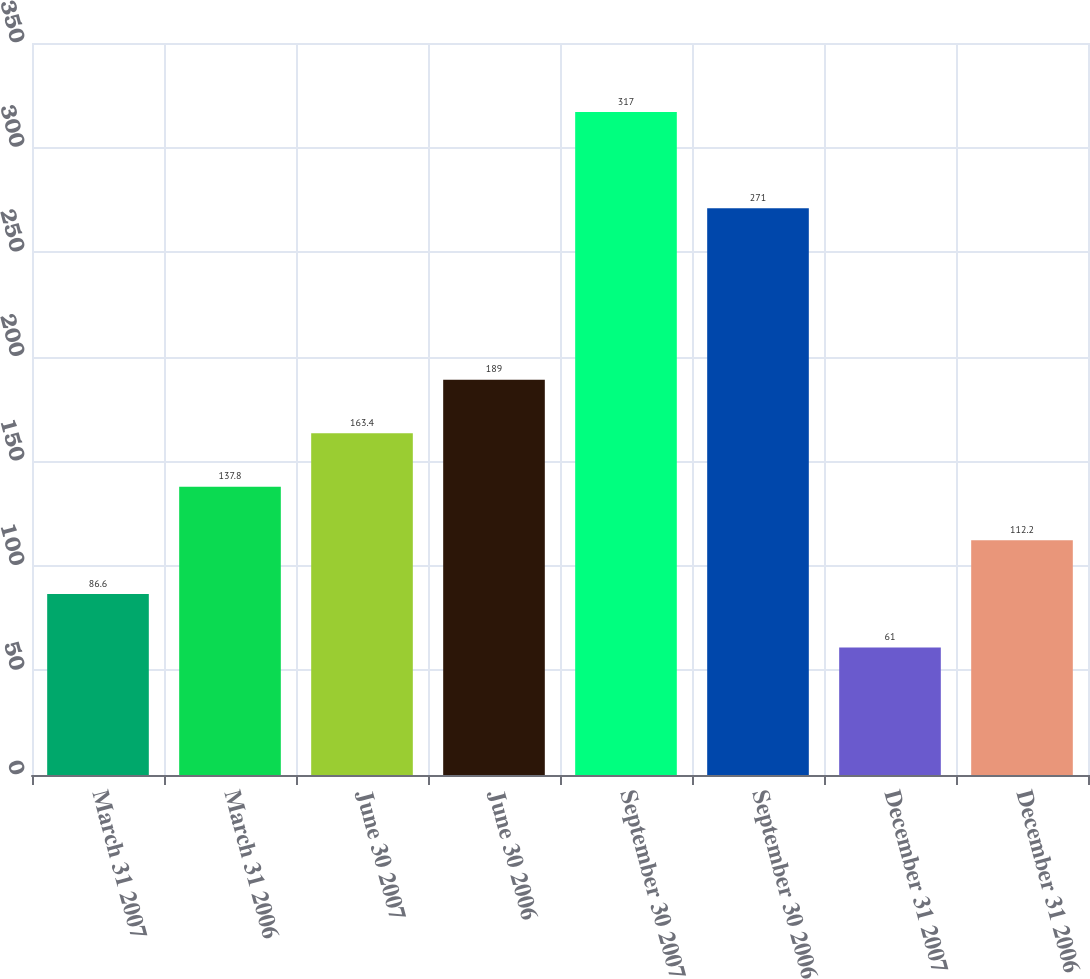Convert chart to OTSL. <chart><loc_0><loc_0><loc_500><loc_500><bar_chart><fcel>March 31 2007<fcel>March 31 2006<fcel>June 30 2007<fcel>June 30 2006<fcel>September 30 2007<fcel>September 30 2006<fcel>December 31 2007<fcel>December 31 2006<nl><fcel>86.6<fcel>137.8<fcel>163.4<fcel>189<fcel>317<fcel>271<fcel>61<fcel>112.2<nl></chart> 